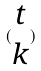<formula> <loc_0><loc_0><loc_500><loc_500>( \begin{matrix} t \\ k \end{matrix} )</formula> 